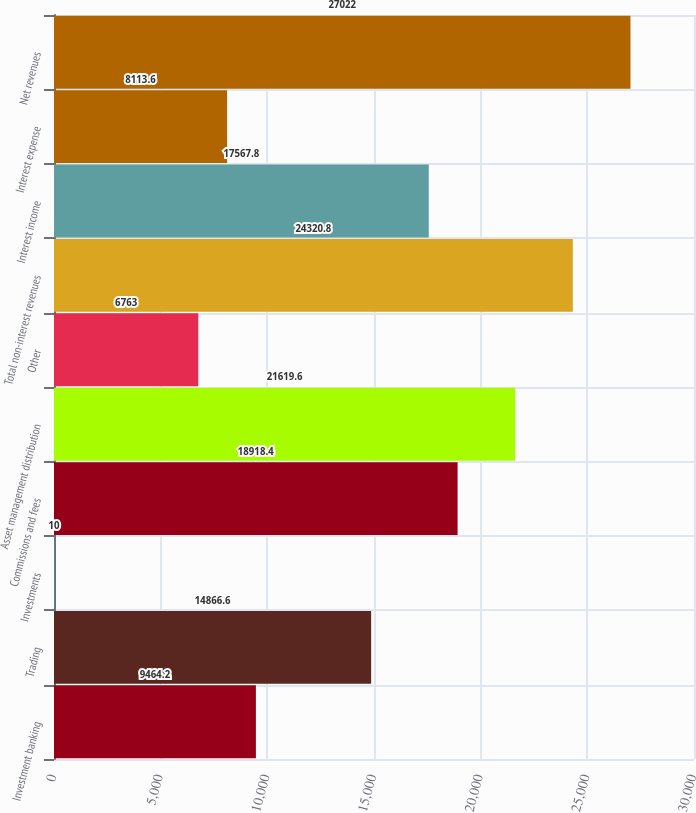Convert chart to OTSL. <chart><loc_0><loc_0><loc_500><loc_500><bar_chart><fcel>Investment banking<fcel>Trading<fcel>Investments<fcel>Commissions and fees<fcel>Asset management distribution<fcel>Other<fcel>Total non-interest revenues<fcel>Interest income<fcel>Interest expense<fcel>Net revenues<nl><fcel>9464.2<fcel>14866.6<fcel>10<fcel>18918.4<fcel>21619.6<fcel>6763<fcel>24320.8<fcel>17567.8<fcel>8113.6<fcel>27022<nl></chart> 